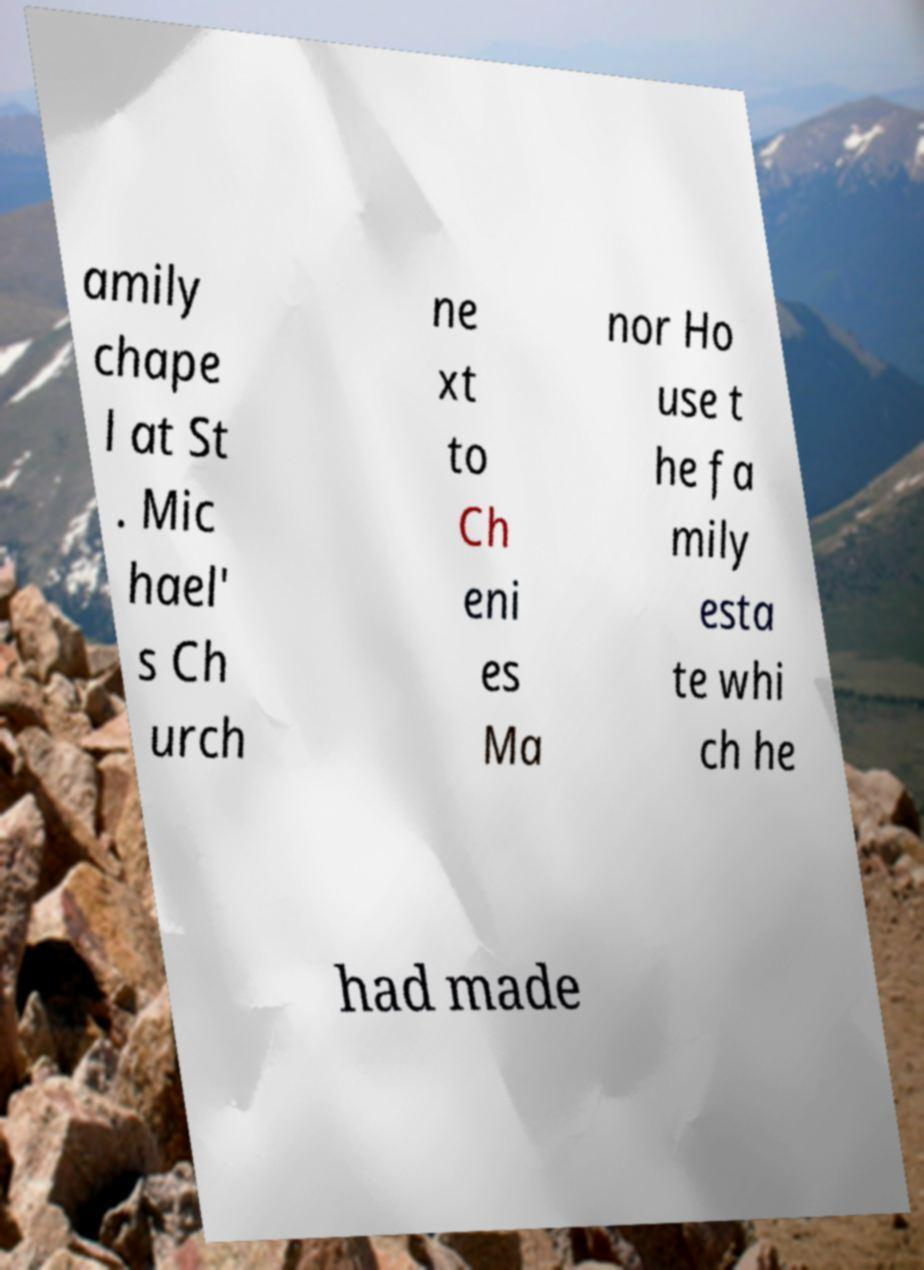Can you accurately transcribe the text from the provided image for me? amily chape l at St . Mic hael' s Ch urch ne xt to Ch eni es Ma nor Ho use t he fa mily esta te whi ch he had made 